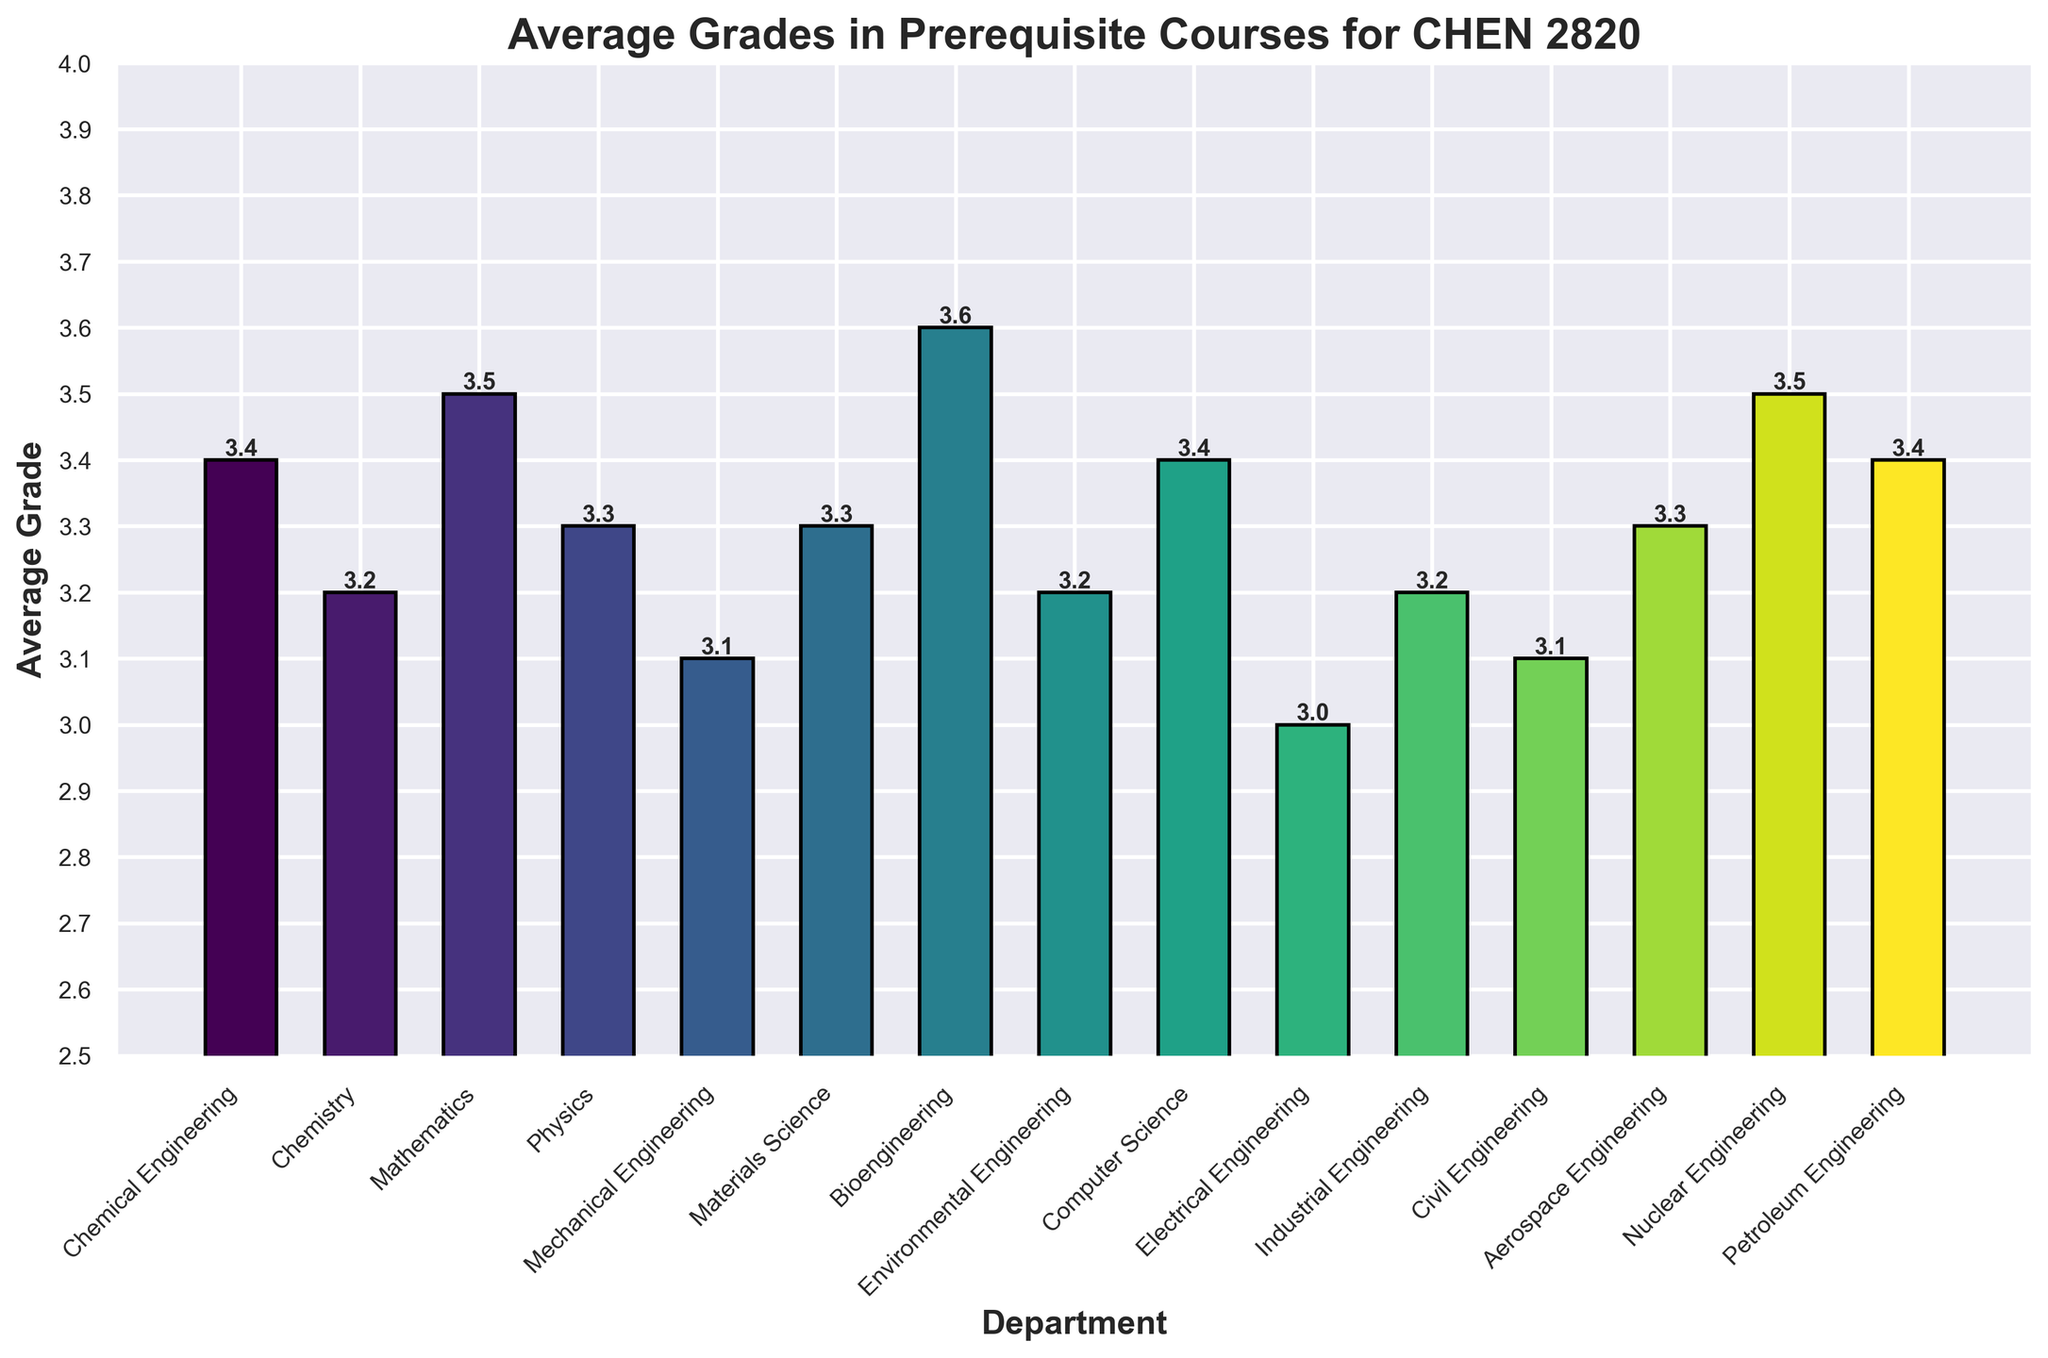Which department has the highest average grade? First, we look at the bars representing each department. The highest bar indicates the department with the highest average grade. Based on the figure, the Bioengineering department has the tallest bar.
Answer: Bioengineering Which department has the lowest average grade? Locate the shortest bar on the bar chart. The Electrical Engineering department's bar is the shortest, indicating it has the lowest average grade.
Answer: Electrical Engineering How many departments have an average grade above 3.4? Count the number of bars taller than the 3.4 mark on the y-axis. From the figure, Bioengineering, Nuclear Engineering, and Mathematics have bars above 3.4.
Answer: 3 What's the average grade difference between the department with the highest grade and the department with the lowest grade? Subtract the lowest average grade from the highest. Bioengineering has the highest at 3.6, and Electrical Engineering has the lowest at 3.0. The difference is 3.6 - 3.0 = 0.6.
Answer: 0.6 Which departments have the same average grade? Identify bars that reach the same height on the y-axis. Chemical Engineering, Computer Science, and Petroleum Engineering all have bars that reach 3.4. Also, Chemistry, Environmental Engineering, and Industrial Engineering, all have bars that reach 3.2. Physics, Materials Science, and Aerospace Engineering all have bars that reach 3.3.
Answer: Chemical Engineering, Computer Science, Petroleum Engineering; Chemistry, Environmental Engineering, Industrial Engineering; Physics, Materials Science, Aerospace Engineering What is the average grade for departments in engineering (Bioengineering, Chemical Engineering, Mechanical Engineering, Electrical Engineering, Industrial Engineering, Civil Engineering, Aerospace Engineering, Nuclear Engineering, Petroleum Engineering)? Sum the average grades of these departments and divide by the number of departments. (3.6 + 3.4 + 3.1 + 3.0 + 3.2 + 3.1 + 3.3 + 3.5 + 3.4) / 9 = 3.29.
Answer: 3.29 Which departments have a median average grade when all departments are sorted by their average grades? List the average grades in order to find the middle value. Departments sorted by average grade: 3.0, 3.1, 3.1, 3.2, 3.2, 3.2, 3.3, 3.3, 3.3, 3.4, 3.4, 3.4, 3.5, 3.5, 3.6. The median grade in this list is 3.3; hence, Physics, Materials Science, and Aerospace Engineering have the median average grade.
Answer: Physics, Materials Science, Aerospace Engineering What's the average grade of Mathematics and Physics combined compared to Chemical Engineering and Computer Science combined? Calculate the combined average for both pairs of departments. (3.5 + 3.3) / 2 = 3.4 for Mathematics and Physics. (3.4 + 3.4) / 2 = 3.4 for Chemical Engineering and Computer Science. Therefore, both combined averages are equal.
Answer: 3.4 and 3.4 